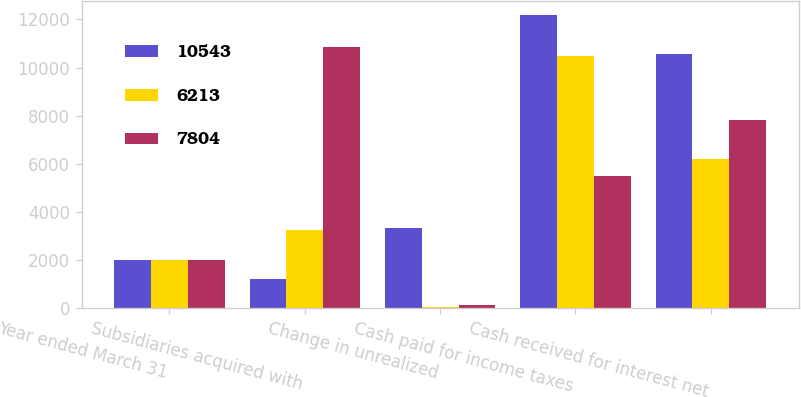<chart> <loc_0><loc_0><loc_500><loc_500><stacked_bar_chart><ecel><fcel>Year ended March 31<fcel>Subsidiaries acquired with<fcel>Change in unrealized<fcel>Cash paid for income taxes<fcel>Cash received for interest net<nl><fcel>10543<fcel>2005<fcel>1191<fcel>3317<fcel>12178<fcel>10543<nl><fcel>6213<fcel>2004<fcel>3246<fcel>37<fcel>10463<fcel>6213<nl><fcel>7804<fcel>2003<fcel>10861<fcel>134<fcel>5491<fcel>7804<nl></chart> 